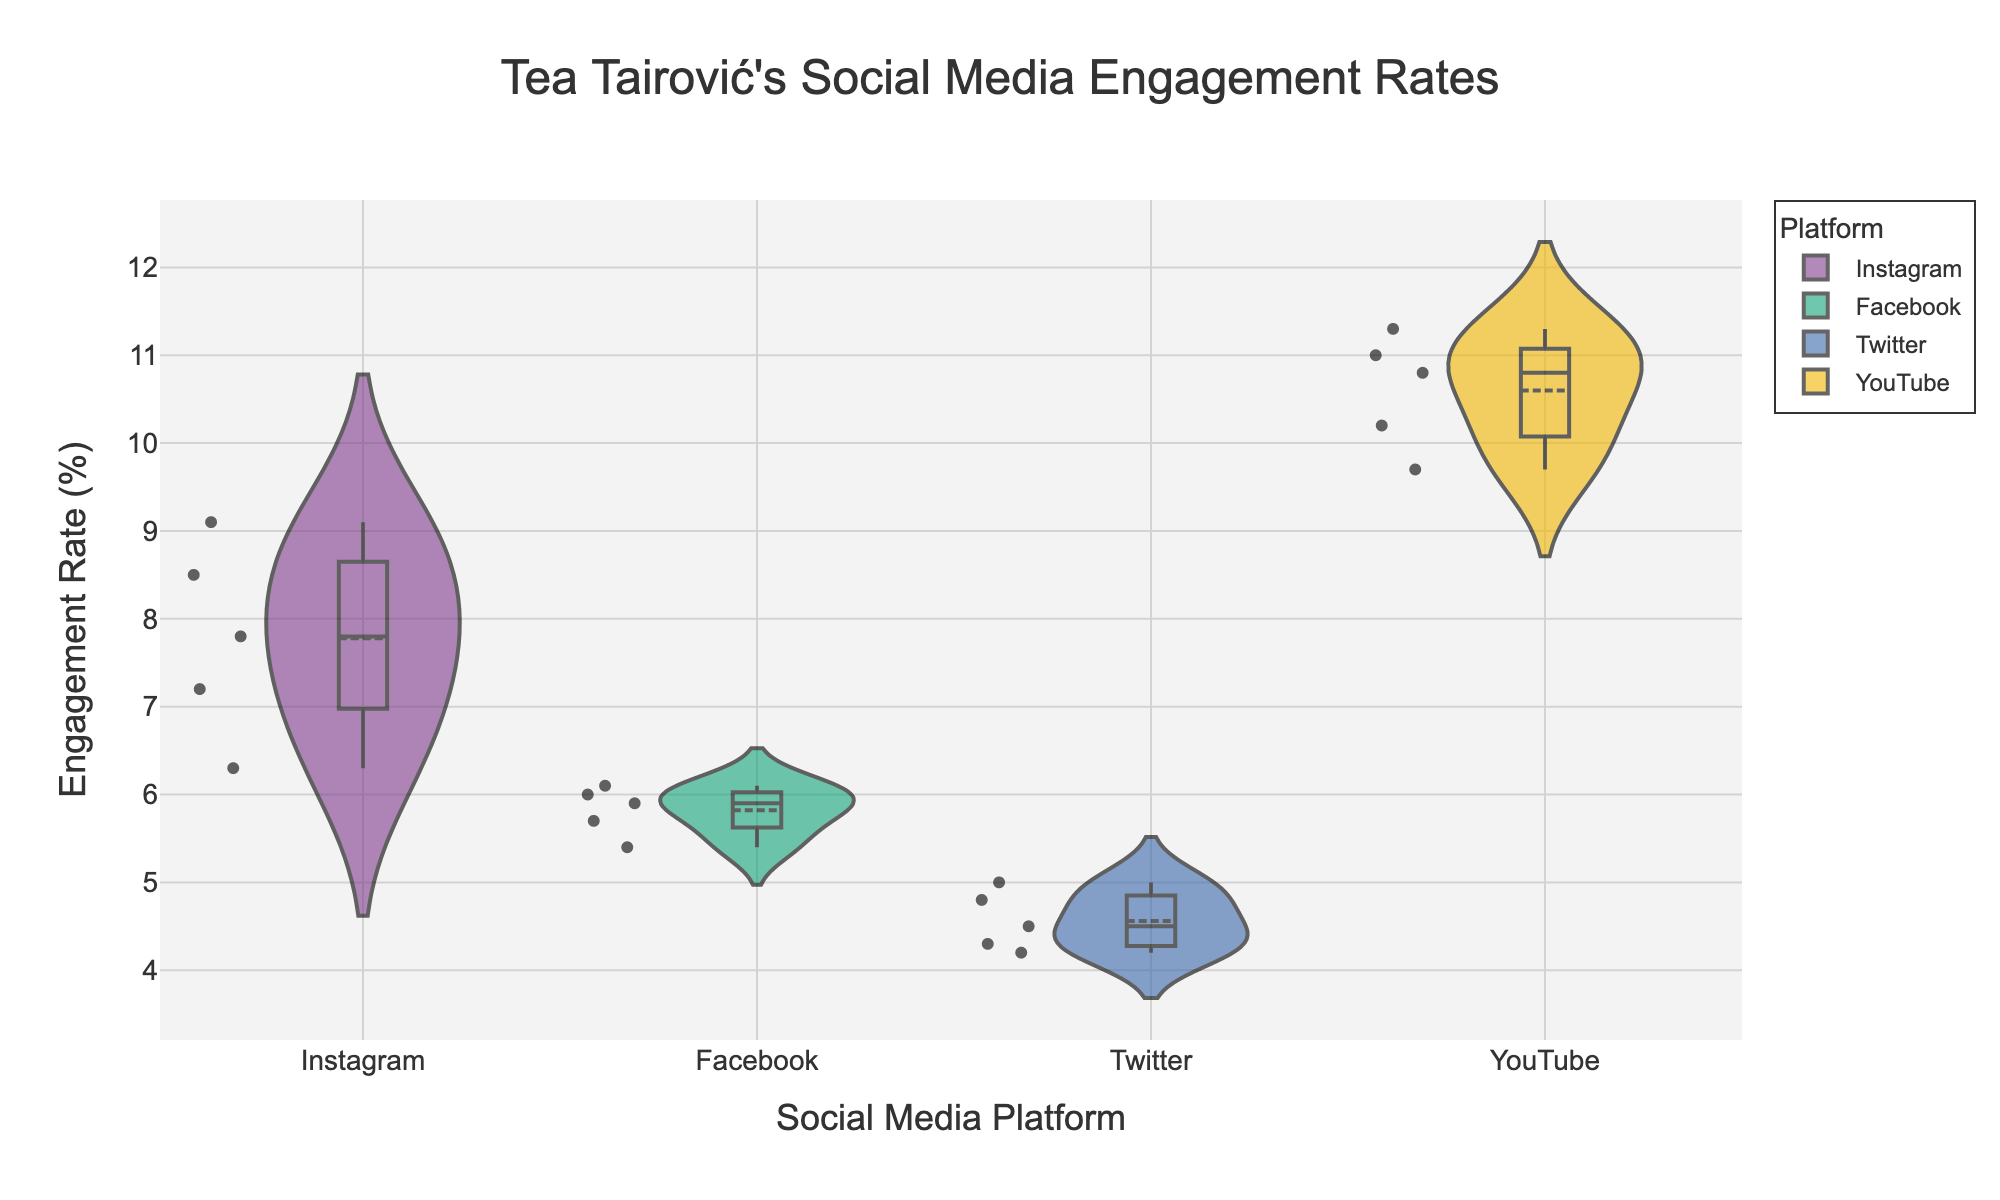what is the title of the figure? The title is usually located at the top of the figure and provides an overview of what the data represents. In this case, it states "Tea Tairović's Social Media Engagement Rates."
Answer: Tea Tairović's Social Media Engagement Rates What does the y-axis represent? The y-axis is labeled with a description of the data measured along it. Here, it is labeled "Engagement Rate (%)", indicating that it represents the percentage engagement rate of social media posts.
Answer: Engagement Rate (%) Which platform has the highest engagement rate on average? Looking at the figure, you can compare the mean lines in the violin plots for each platform. The platform with the highest position for its mean line has the highest average engagement. YouTube has the highest mean line.
Answer: YouTube How many platforms are compared in the figure? The figure compares distinct categories, each represented by a separate violin plot. The labels on the x-axis indicate there are four platforms: Instagram, Facebook, Twitter, and YouTube.
Answer: Four What is the range of engagement rates for Tea Tairović's posts on Twitter? To determine the range, observe the minimum and maximum points in the Twitter violin plot. Twitter's engagement rates range from 4.2% to 5.0%.
Answer: 4.2% to 5.0% Comparing Instagram and Facebook, which platform has a wider range of engagement rates? The range of engagement rates is assessed by the spread of the violin plots. Instagram has engagement rates ranging roughly from 6.3% to 9.1%, while Facebook's range is from 5.4% to 6.1%. Therefore, Instagram has a wider range.
Answer: Instagram Is there any overlap in engagement rates between Instagram and YouTube? By comparing the ranges of the violin plots for Instagram and YouTube, determine if they share any common values. Instagram ranges from 6.3% to 9.1%, and YouTube ranges from 9.7% to 11.3%. There is no overlap.
Answer: No Which platform shows the least variability in engagement rates? Variability is observed by the width of the violin plots. The narrower the plot, the less variability it represents. Twitter has the narrowest violin plot, indicating the least variability.
Answer: Twitter What is the maximum engagement rate observed across all platforms? The maximum engagement rate is the highest point in all the violin plots. The highest point is seen in YouTube's plot at 11.3%.
Answer: 11.3% Do any platforms show an engagement rate below 5%? To check for engagement rates below 5%, observe the lower ends of the violin plots. Twitter has engagement rates starting from 4.2%, which is below 5%.
Answer: Yes, Twitter 